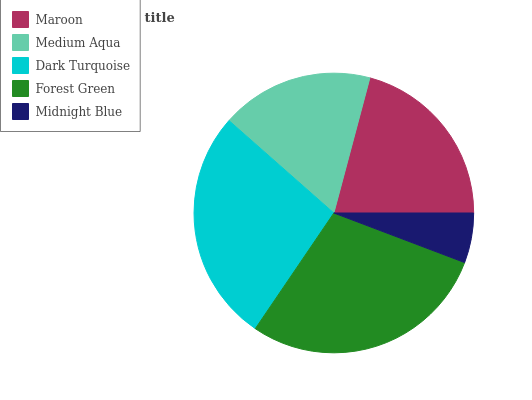Is Midnight Blue the minimum?
Answer yes or no. Yes. Is Forest Green the maximum?
Answer yes or no. Yes. Is Medium Aqua the minimum?
Answer yes or no. No. Is Medium Aqua the maximum?
Answer yes or no. No. Is Maroon greater than Medium Aqua?
Answer yes or no. Yes. Is Medium Aqua less than Maroon?
Answer yes or no. Yes. Is Medium Aqua greater than Maroon?
Answer yes or no. No. Is Maroon less than Medium Aqua?
Answer yes or no. No. Is Maroon the high median?
Answer yes or no. Yes. Is Maroon the low median?
Answer yes or no. Yes. Is Forest Green the high median?
Answer yes or no. No. Is Midnight Blue the low median?
Answer yes or no. No. 